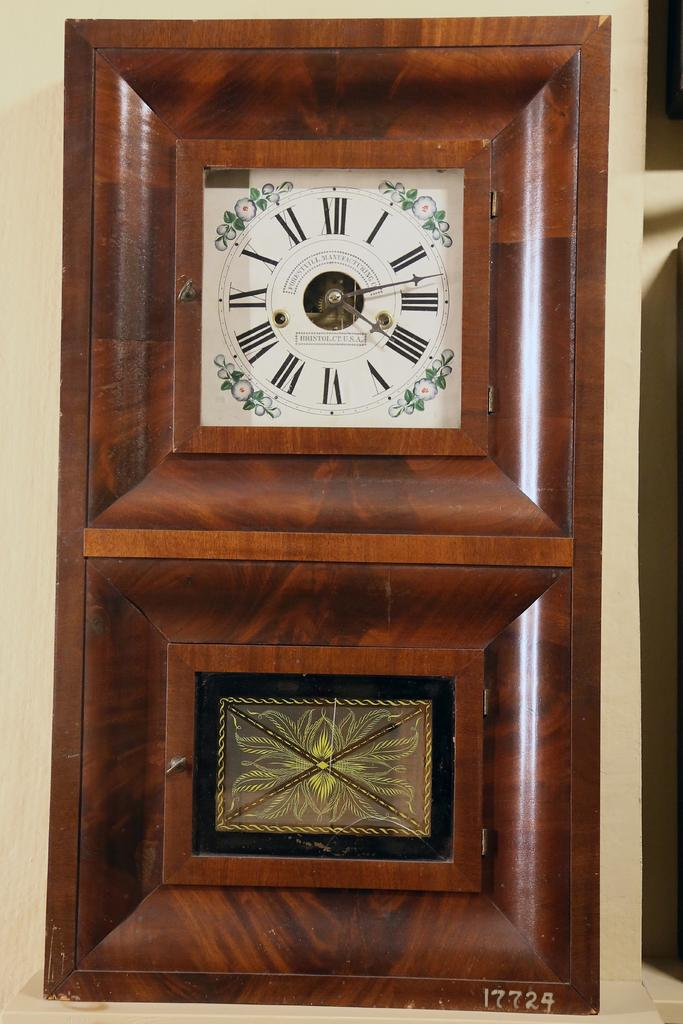Provide a one-sentence caption for the provided image. many roman numerals that are on a clock. 